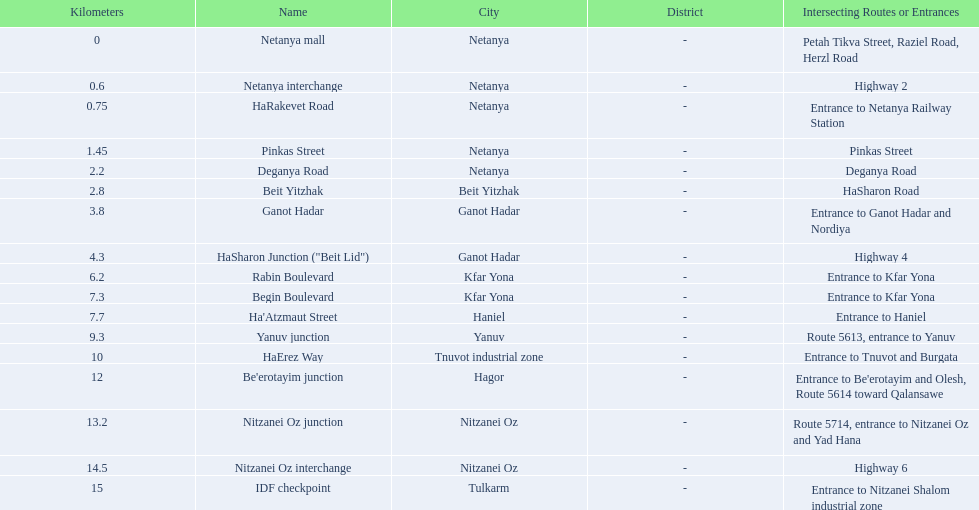What is the intersecting route of rabin boulevard? Entrance to Kfar Yona. Which portion has this intersecting route? Begin Boulevard. 